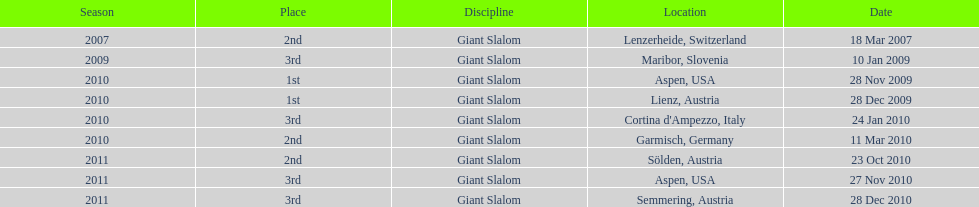What was the finishing place of the last race in december 2010? 3rd. 